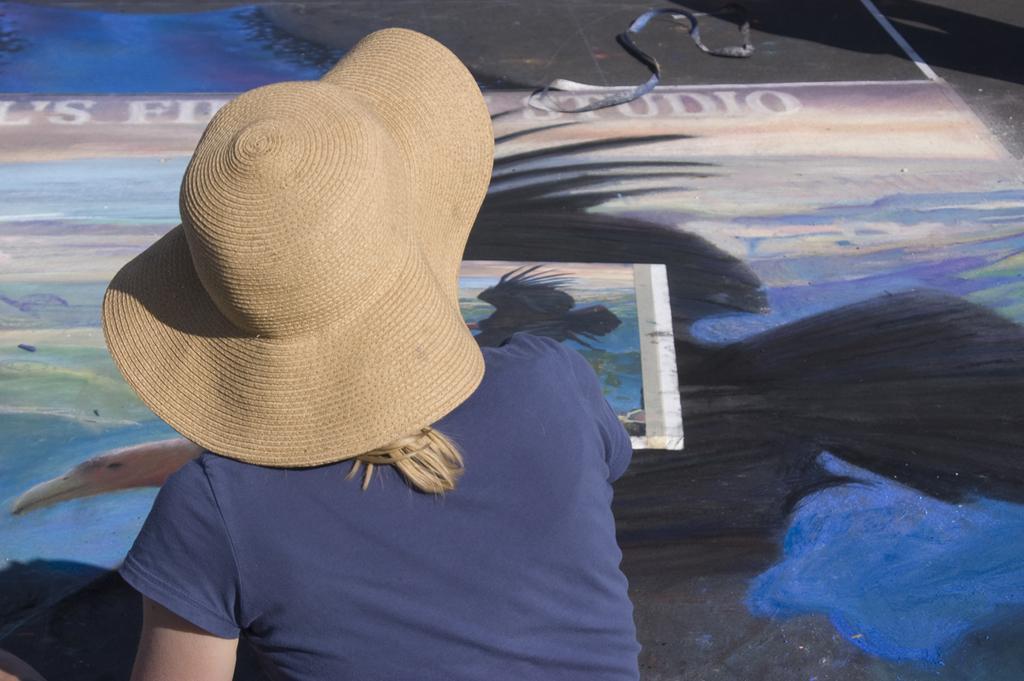In one or two sentences, can you explain what this image depicts? In this image I can see a woman wearing a cap on her head , in front of her there is a painting on floor and rope visible at the top. 